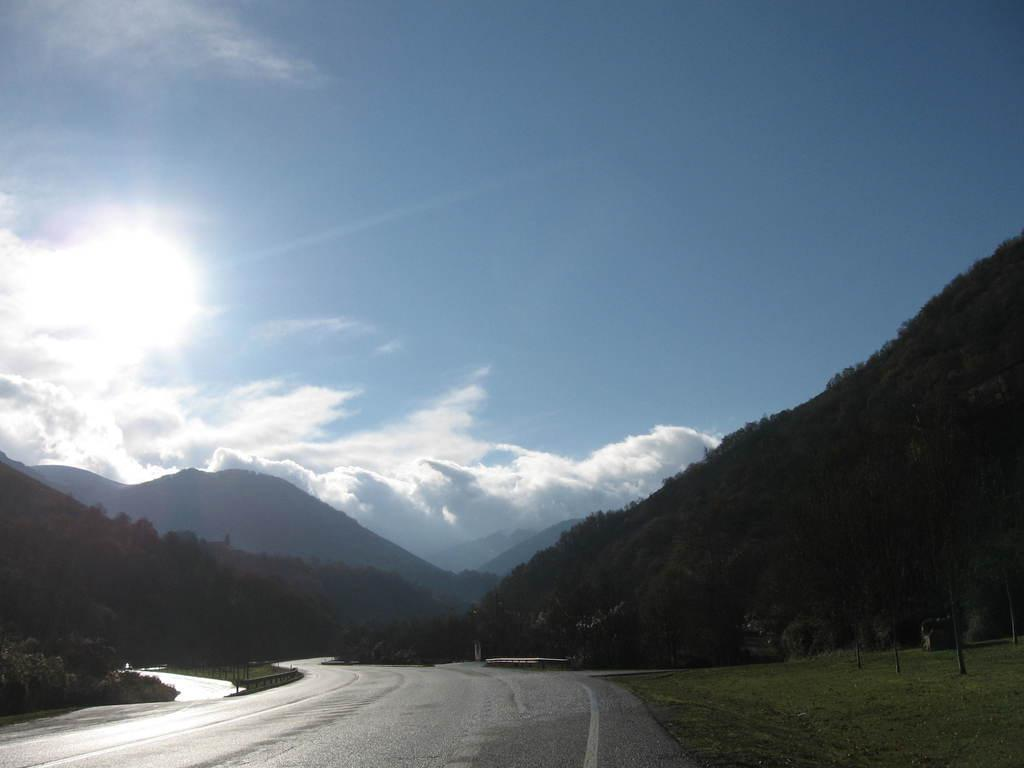What is the main feature of the image? There is a road in the image. What can be seen in the distance behind the road? There are mountains in the background of the image. What part of the natural environment is visible in the image? The sky is visible in the image. What grade of addition is being taught in the image? There is no indication of any educational activity or subject matter in the image. 